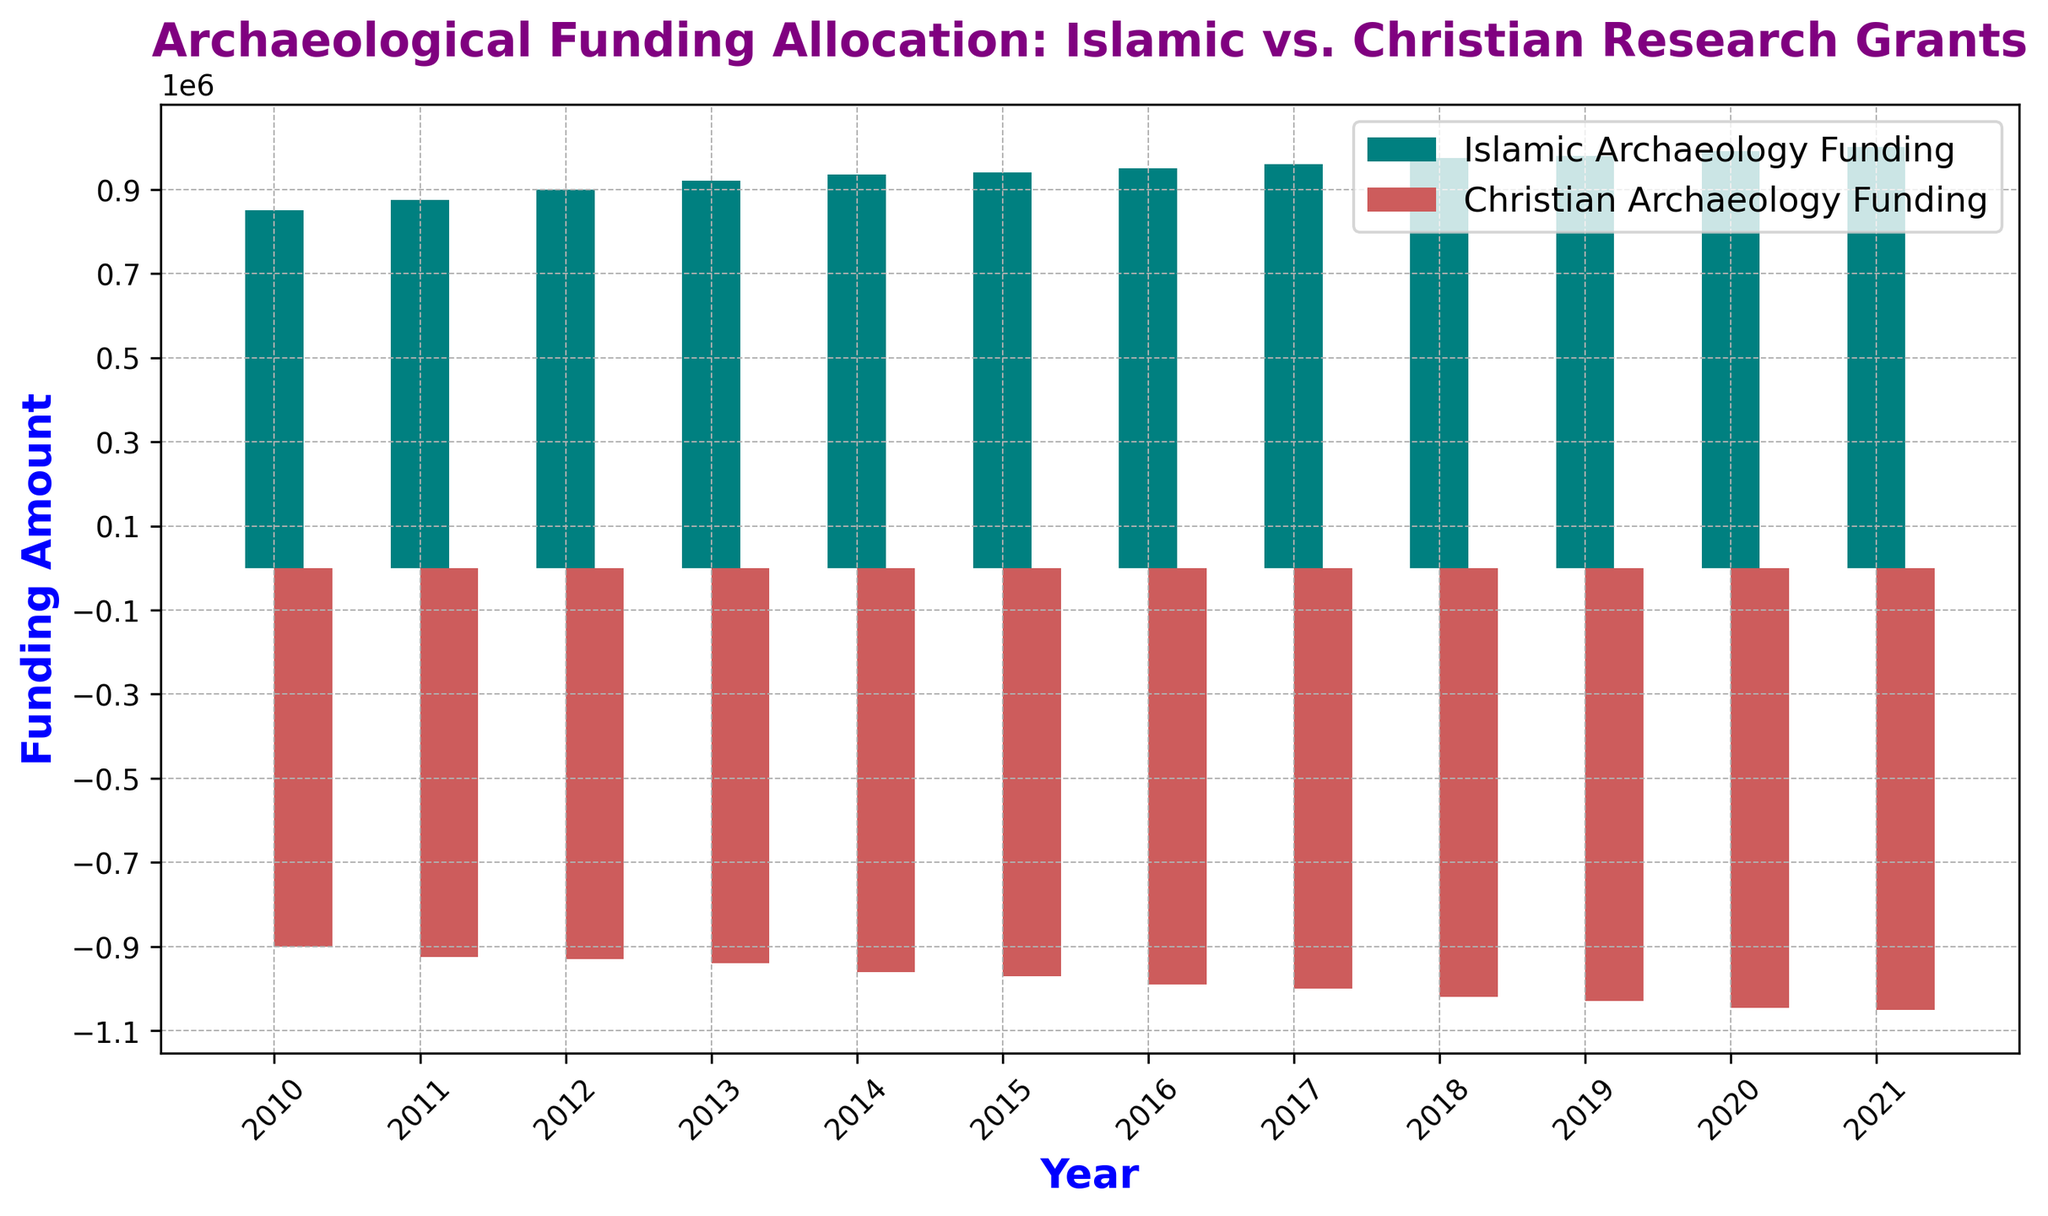What is the total funding for Islamic archaeology over the given years? To find the total funding for Islamic archaeology, add the yearly funding amounts provided: 850000 + 875000 + 900000 + 920000 + 935000 + 940000 + 950000 + 960000 + 975000 + 980000 + 990000 + 1000000 = 11375000
Answer: 11375000 What is the difference in funding between Islamic and Christian archaeology in 2021? Subtract the Christian archaeology budget (which is negative) from the Islamic archaeology budget: 1000000 - (-1050000) = 2050000
Answer: 2050000 Which year saw the highest funding for Islamic archaeology? By looking at the heights of the teal bars representing Islamic archaeology, the highest bar is in 2021.
Answer: 2021 How does the trend in Islamic archaeology funding compare to Christian archaeology funding from 2015 to 2021? From 2015 to 2021, Islamic archaeology funding shows an increasing trend from 940000 to 1000000. In contrast, Christian archaeology funding also shows an increasing negative trend (increasing deficit) from -970000 to -1050000.
Answer: Increasing for both, but Christian funding has a growing deficit What is the average annual funding for Christian archaeology over the span of 2010 to 2021? Add up the yearly negative funding amounts and divide by the number of years. Sum = (-900000 + -925000 + -930000 + -940000 + -960000 + -970000 + -990000 + -1000000 + -1020000 + -1030000 + -1045000 + -1050000) = -11695000. Then, -11695000 / 12 = -974583.33
Answer: -974583.33 Which year had the smallest gap between Islamic and Christian archaeology funding? Calculate the gap for each year and identify the smallest: 
2010: 850000 - (-900000) = 1750000
2011: 875000 - (-925000) = 1800000
2012: 900000 - (-930000) = 1830000
2013: 920000 - (-940000) = 1860000
2014: 935000 - (-960000) = 1895000
2015: 940000 - (-970000) = 1910000
2016: 950000 - (-990000) = 1940000
2017: 960000 - (-1000000) = 1960000
2018: 975000 - (-1020000) = 1995000
2019: 980000 - (-1030000) = 2010000
2020: 990000 - (-1045000) = 2035000
2021: 1000000 - (-1050000) = 2050000
The smallest gap is in 2010.
Answer: 2010 Which year had the steepest increase in funding for Islamic archaeology? Compare the yearly differences in funding amounts:
2010-11: 875000 - 850000 = 25000
2011-12: 900000 - 875000 = 25000
2012-13: 920000 - 900000 = 20000
2013-14: 935000 - 920000 = 15000
2014-15: 940000 - 935000 = 5000
2015-16: 950000 - 940000 = 10000
2016-17: 960000 - 950000 = 10000
2017-18: 975000 - 960000 = 15000
2018-19: 980000 - 975000 = 5000
2019-20: 990000 - 980000 = 10000
2020-21: 1000000 - 990000 = 10000
The years 2010-11 and 2011-12 both had the steepest increase of 25000.
Answer: 2010-11 and 2011-12 